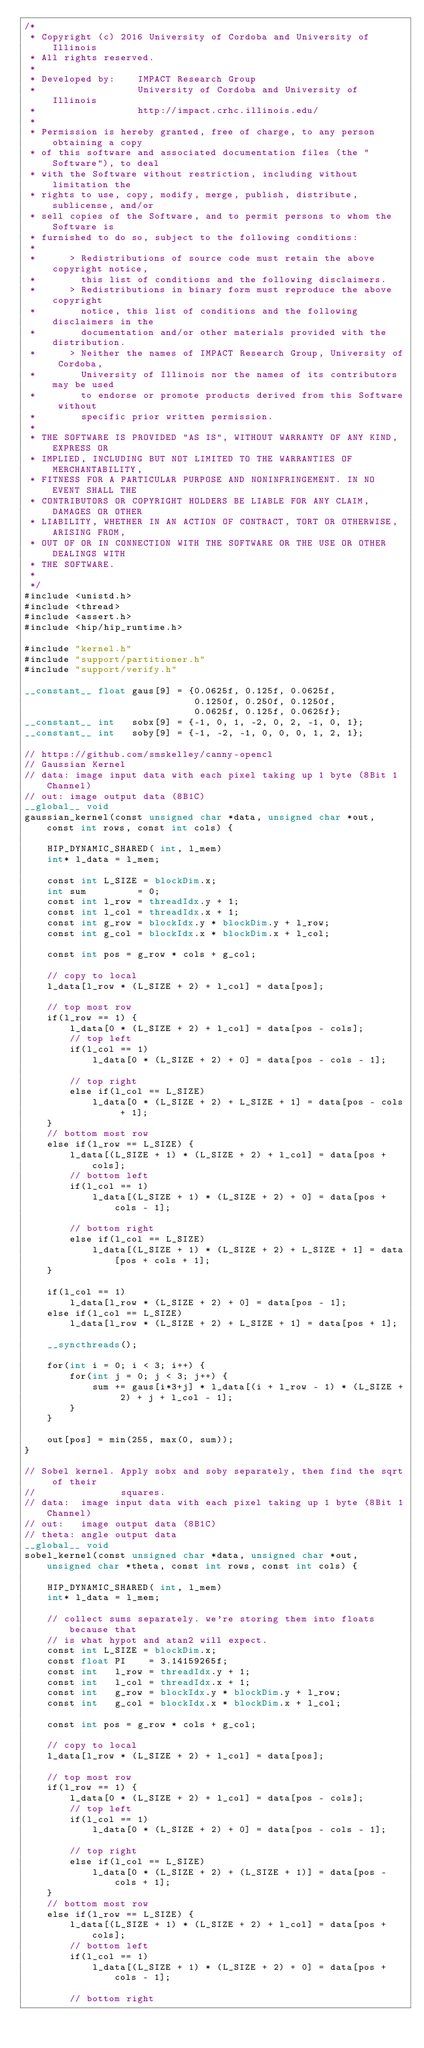Convert code to text. <code><loc_0><loc_0><loc_500><loc_500><_Cuda_>/*
 * Copyright (c) 2016 University of Cordoba and University of Illinois
 * All rights reserved.
 *
 * Developed by:    IMPACT Research Group
 *                  University of Cordoba and University of Illinois
 *                  http://impact.crhc.illinois.edu/
 *
 * Permission is hereby granted, free of charge, to any person obtaining a copy
 * of this software and associated documentation files (the "Software"), to deal
 * with the Software without restriction, including without limitation the 
 * rights to use, copy, modify, merge, publish, distribute, sublicense, and/or
 * sell copies of the Software, and to permit persons to whom the Software is
 * furnished to do so, subject to the following conditions:
 *
 *      > Redistributions of source code must retain the above copyright notice,
 *        this list of conditions and the following disclaimers.
 *      > Redistributions in binary form must reproduce the above copyright
 *        notice, this list of conditions and the following disclaimers in the
 *        documentation and/or other materials provided with the distribution.
 *      > Neither the names of IMPACT Research Group, University of Cordoba, 
 *        University of Illinois nor the names of its contributors may be used 
 *        to endorse or promote products derived from this Software without 
 *        specific prior written permission.
 *
 * THE SOFTWARE IS PROVIDED "AS IS", WITHOUT WARRANTY OF ANY KIND, EXPRESS OR
 * IMPLIED, INCLUDING BUT NOT LIMITED TO THE WARRANTIES OF MERCHANTABILITY,
 * FITNESS FOR A PARTICULAR PURPOSE AND NONINFRINGEMENT. IN NO EVENT SHALL THE 
 * CONTRIBUTORS OR COPYRIGHT HOLDERS BE LIABLE FOR ANY CLAIM, DAMAGES OR OTHER
 * LIABILITY, WHETHER IN AN ACTION OF CONTRACT, TORT OR OTHERWISE, ARISING FROM,
 * OUT OF OR IN CONNECTION WITH THE SOFTWARE OR THE USE OR OTHER DEALINGS WITH
 * THE SOFTWARE.
 *
 */
#include <unistd.h>
#include <thread>
#include <assert.h>
#include <hip/hip_runtime.h>

#include "kernel.h"
#include "support/partitioner.h"
#include "support/verify.h"

__constant__ float gaus[9] = {0.0625f, 0.125f, 0.0625f, 
                              0.1250f, 0.250f, 0.1250f, 
                              0.0625f, 0.125f, 0.0625f};
__constant__ int   sobx[9] = {-1, 0, 1, -2, 0, 2, -1, 0, 1};
__constant__ int   soby[9] = {-1, -2, -1, 0, 0, 0, 1, 2, 1};

// https://github.com/smskelley/canny-opencl
// Gaussian Kernel
// data: image input data with each pixel taking up 1 byte (8Bit 1Channel)
// out: image output data (8B1C)
__global__ void 
gaussian_kernel(const unsigned char *data, unsigned char *out, const int rows, const int cols) {

    HIP_DYNAMIC_SHARED( int, l_mem)
    int* l_data = l_mem;

    const int L_SIZE = blockDim.x;
    int sum         = 0;
    const int l_row = threadIdx.y + 1;
    const int l_col = threadIdx.x + 1;
    const int g_row = blockIdx.y * blockDim.y + l_row;
    const int g_col = blockIdx.x * blockDim.x + l_col;

    const int pos = g_row * cols + g_col;

    // copy to local
    l_data[l_row * (L_SIZE + 2) + l_col] = data[pos];

    // top most row
    if(l_row == 1) {
        l_data[0 * (L_SIZE + 2) + l_col] = data[pos - cols];
        // top left
        if(l_col == 1)
            l_data[0 * (L_SIZE + 2) + 0] = data[pos - cols - 1];

        // top right
        else if(l_col == L_SIZE)
            l_data[0 * (L_SIZE + 2) + L_SIZE + 1] = data[pos - cols + 1];
    }
    // bottom most row
    else if(l_row == L_SIZE) {
        l_data[(L_SIZE + 1) * (L_SIZE + 2) + l_col] = data[pos + cols];
        // bottom left
        if(l_col == 1)
            l_data[(L_SIZE + 1) * (L_SIZE + 2) + 0] = data[pos + cols - 1];

        // bottom right
        else if(l_col == L_SIZE)
            l_data[(L_SIZE + 1) * (L_SIZE + 2) + L_SIZE + 1] = data[pos + cols + 1];
    }

    if(l_col == 1)
        l_data[l_row * (L_SIZE + 2) + 0] = data[pos - 1];
    else if(l_col == L_SIZE)
        l_data[l_row * (L_SIZE + 2) + L_SIZE + 1] = data[pos + 1];

    __syncthreads();

    for(int i = 0; i < 3; i++) {
        for(int j = 0; j < 3; j++) {
            sum += gaus[i*3+j] * l_data[(i + l_row - 1) * (L_SIZE + 2) + j + l_col - 1];
        }
    }

    out[pos] = min(255, max(0, sum));
}

// Sobel kernel. Apply sobx and soby separately, then find the sqrt of their
//               squares.
// data:  image input data with each pixel taking up 1 byte (8Bit 1Channel)
// out:   image output data (8B1C)
// theta: angle output data
__global__ void 
sobel_kernel(const unsigned char *data, unsigned char *out, unsigned char *theta, const int rows, const int cols) {

    HIP_DYNAMIC_SHARED( int, l_mem)
    int* l_data = l_mem;

    // collect sums separately. we're storing them into floats because that
    // is what hypot and atan2 will expect.
    const int L_SIZE = blockDim.x;
    const float PI    = 3.14159265f;
    const int   l_row = threadIdx.y + 1;
    const int   l_col = threadIdx.x + 1;
    const int   g_row = blockIdx.y * blockDim.y + l_row;
    const int   g_col = blockIdx.x * blockDim.x + l_col;

    const int pos = g_row * cols + g_col;

    // copy to local
    l_data[l_row * (L_SIZE + 2) + l_col] = data[pos];

    // top most row
    if(l_row == 1) {
        l_data[0 * (L_SIZE + 2) + l_col] = data[pos - cols];
        // top left
        if(l_col == 1)
            l_data[0 * (L_SIZE + 2) + 0] = data[pos - cols - 1];

        // top right
        else if(l_col == L_SIZE)
            l_data[0 * (L_SIZE + 2) + (L_SIZE + 1)] = data[pos - cols + 1];
    }
    // bottom most row
    else if(l_row == L_SIZE) {
        l_data[(L_SIZE + 1) * (L_SIZE + 2) + l_col] = data[pos + cols];
        // bottom left
        if(l_col == 1)
            l_data[(L_SIZE + 1) * (L_SIZE + 2) + 0] = data[pos + cols - 1];

        // bottom right</code> 